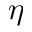<formula> <loc_0><loc_0><loc_500><loc_500>\eta</formula> 